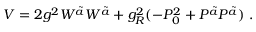<formula> <loc_0><loc_0><loc_500><loc_500>V = 2 g ^ { 2 } W ^ { \tilde { a } } W ^ { \tilde { a } } + g _ { R } ^ { 2 } ( - P _ { 0 } ^ { 2 } + P ^ { \tilde { a } } P ^ { \tilde { a } } ) \ .</formula> 